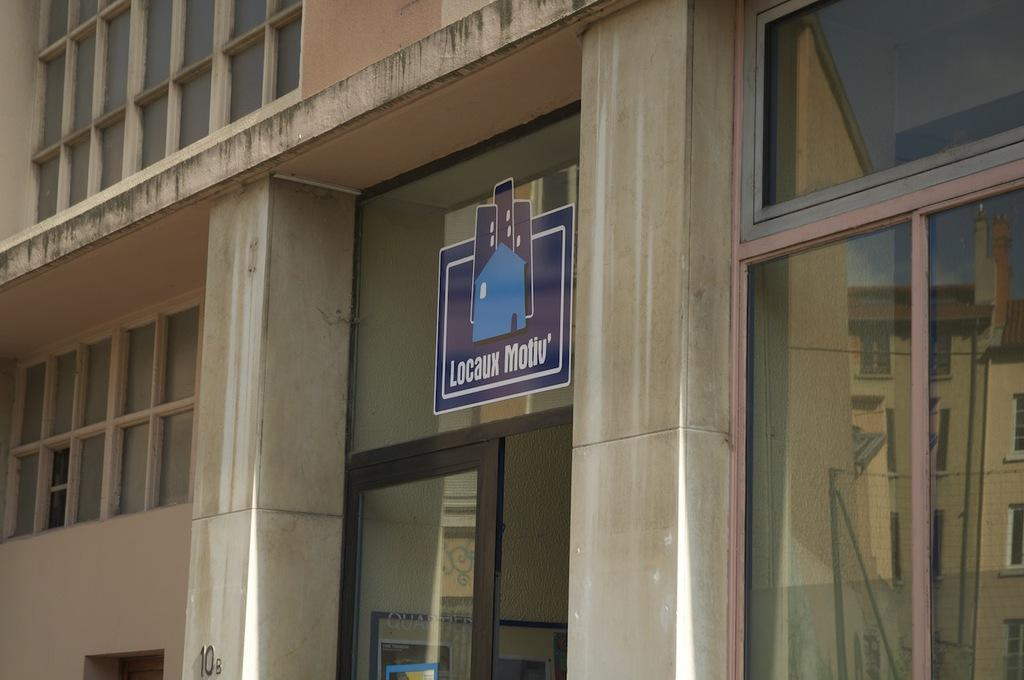What type of structure is visible in the image? There is a building in the image. What features can be seen on the building? The building has windows and a door. What else is present in the image besides the building? There is a board in the image. Can you tell if the image was taken during the day or night? The image was likely taken during the day. Where is the orange located in the image? There is no orange present in the image. What type of map is shown on the board in the image? There is no map present on the board in the image. 